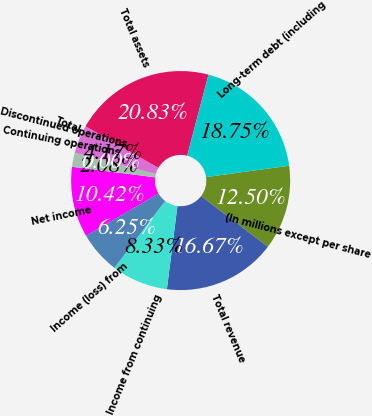<chart> <loc_0><loc_0><loc_500><loc_500><pie_chart><fcel>(In millions except per share<fcel>Total revenue<fcel>Income from continuing<fcel>Income (loss) from<fcel>Net income<fcel>Continuing operations<fcel>Discontinued operations<fcel>Total<fcel>Total assets<fcel>Long-term debt (including<nl><fcel>12.5%<fcel>16.67%<fcel>8.33%<fcel>6.25%<fcel>10.42%<fcel>2.08%<fcel>0.0%<fcel>4.17%<fcel>20.83%<fcel>18.75%<nl></chart> 